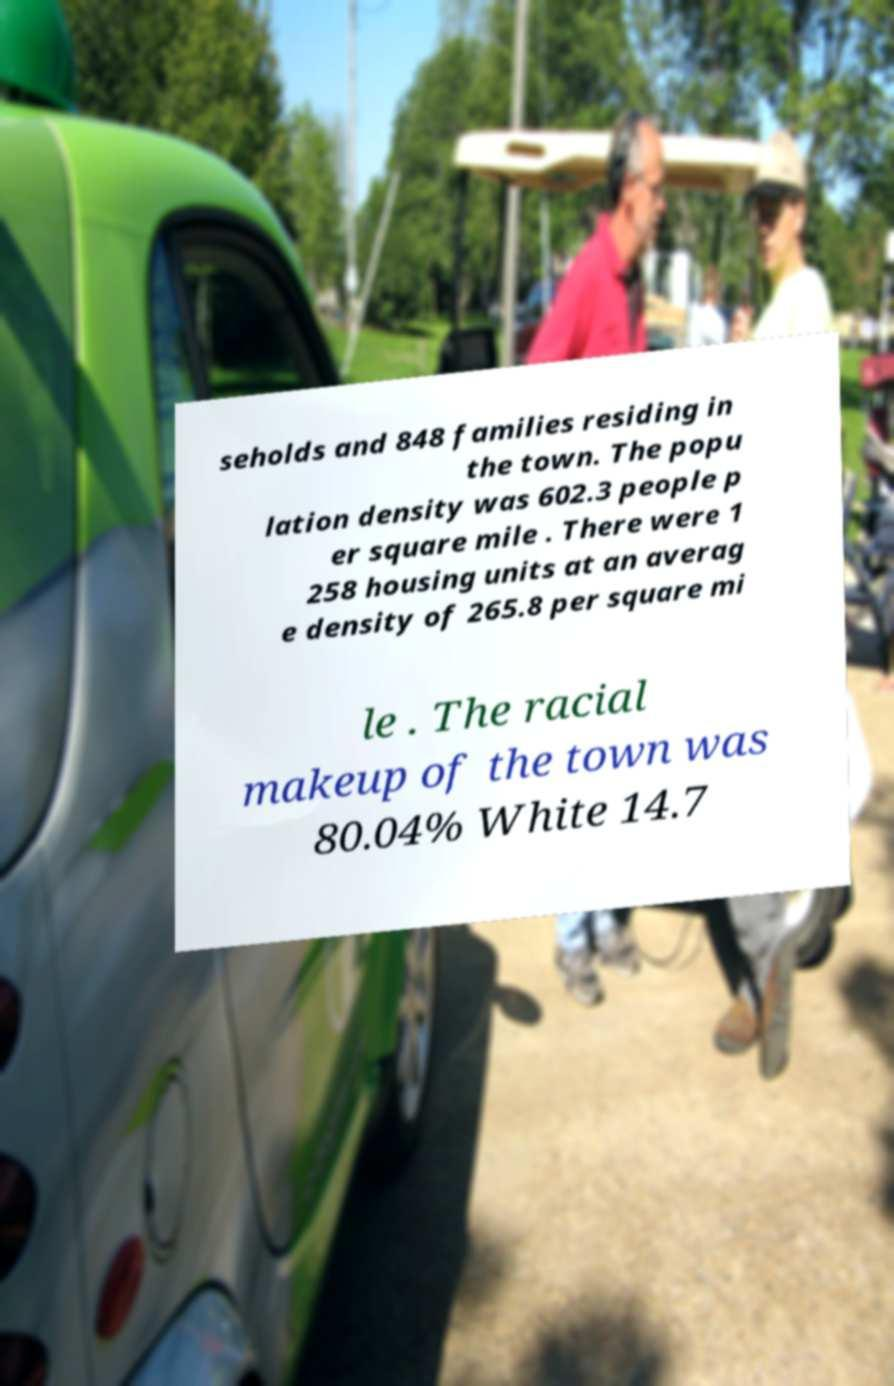Please read and relay the text visible in this image. What does it say? seholds and 848 families residing in the town. The popu lation density was 602.3 people p er square mile . There were 1 258 housing units at an averag e density of 265.8 per square mi le . The racial makeup of the town was 80.04% White 14.7 